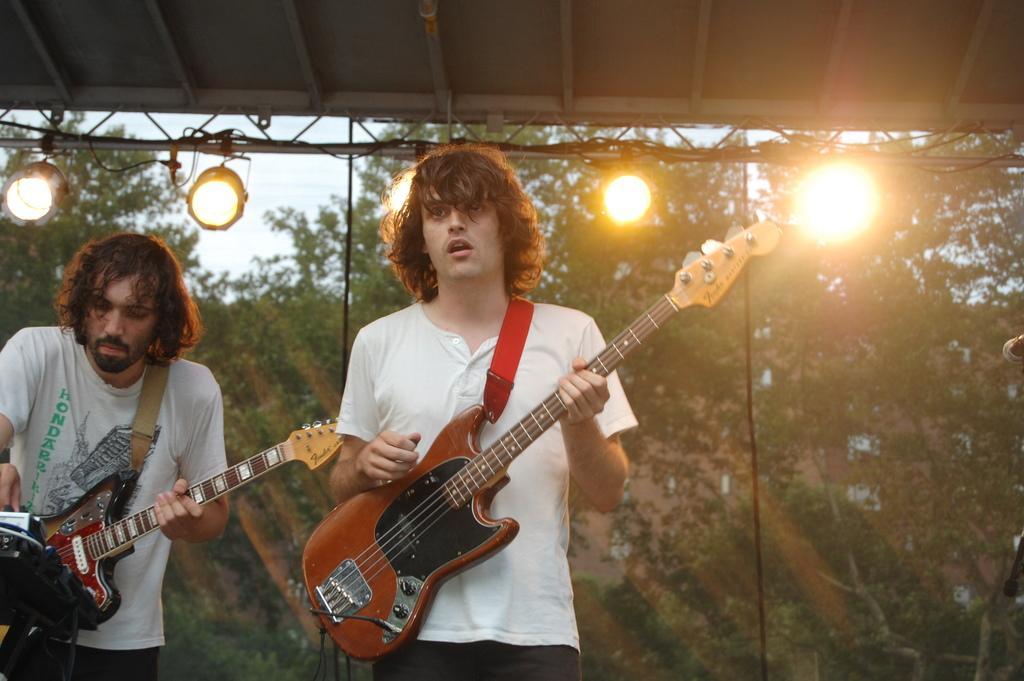In one or two sentences, can you explain what this image depicts? In this picture we can see two men holding guitars in their hands and playing it and in background we can see lights, trees. 